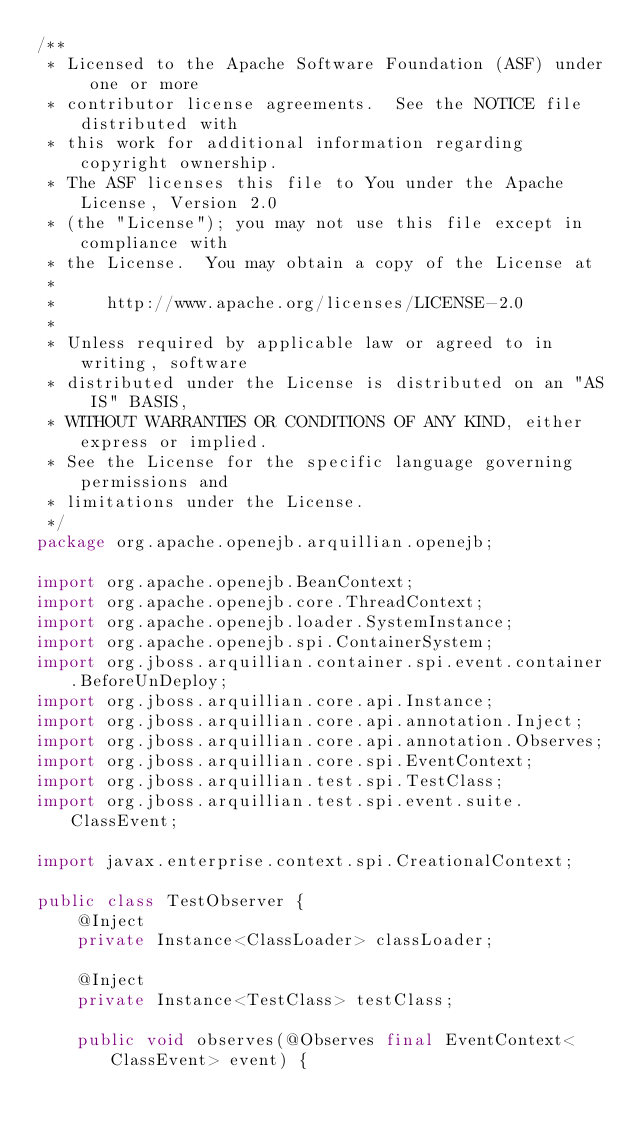<code> <loc_0><loc_0><loc_500><loc_500><_Java_>/**
 * Licensed to the Apache Software Foundation (ASF) under one or more
 * contributor license agreements.  See the NOTICE file distributed with
 * this work for additional information regarding copyright ownership.
 * The ASF licenses this file to You under the Apache License, Version 2.0
 * (the "License"); you may not use this file except in compliance with
 * the License.  You may obtain a copy of the License at
 *
 *     http://www.apache.org/licenses/LICENSE-2.0
 *
 * Unless required by applicable law or agreed to in writing, software
 * distributed under the License is distributed on an "AS IS" BASIS,
 * WITHOUT WARRANTIES OR CONDITIONS OF ANY KIND, either express or implied.
 * See the License for the specific language governing permissions and
 * limitations under the License.
 */
package org.apache.openejb.arquillian.openejb;

import org.apache.openejb.BeanContext;
import org.apache.openejb.core.ThreadContext;
import org.apache.openejb.loader.SystemInstance;
import org.apache.openejb.spi.ContainerSystem;
import org.jboss.arquillian.container.spi.event.container.BeforeUnDeploy;
import org.jboss.arquillian.core.api.Instance;
import org.jboss.arquillian.core.api.annotation.Inject;
import org.jboss.arquillian.core.api.annotation.Observes;
import org.jboss.arquillian.core.spi.EventContext;
import org.jboss.arquillian.test.spi.TestClass;
import org.jboss.arquillian.test.spi.event.suite.ClassEvent;

import javax.enterprise.context.spi.CreationalContext;

public class TestObserver {
    @Inject
    private Instance<ClassLoader> classLoader;

    @Inject
    private Instance<TestClass> testClass;

    public void observes(@Observes final EventContext<ClassEvent> event) {</code> 